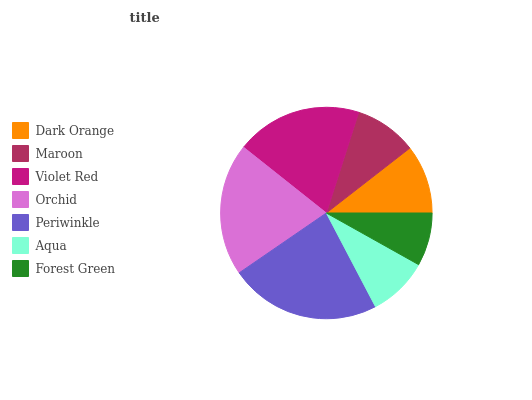Is Forest Green the minimum?
Answer yes or no. Yes. Is Periwinkle the maximum?
Answer yes or no. Yes. Is Maroon the minimum?
Answer yes or no. No. Is Maroon the maximum?
Answer yes or no. No. Is Dark Orange greater than Maroon?
Answer yes or no. Yes. Is Maroon less than Dark Orange?
Answer yes or no. Yes. Is Maroon greater than Dark Orange?
Answer yes or no. No. Is Dark Orange less than Maroon?
Answer yes or no. No. Is Dark Orange the high median?
Answer yes or no. Yes. Is Dark Orange the low median?
Answer yes or no. Yes. Is Orchid the high median?
Answer yes or no. No. Is Violet Red the low median?
Answer yes or no. No. 